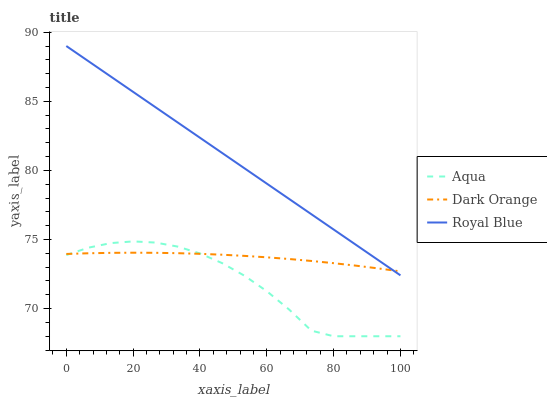Does Aqua have the minimum area under the curve?
Answer yes or no. Yes. Does Royal Blue have the maximum area under the curve?
Answer yes or no. Yes. Does Royal Blue have the minimum area under the curve?
Answer yes or no. No. Does Aqua have the maximum area under the curve?
Answer yes or no. No. Is Royal Blue the smoothest?
Answer yes or no. Yes. Is Aqua the roughest?
Answer yes or no. Yes. Is Aqua the smoothest?
Answer yes or no. No. Is Royal Blue the roughest?
Answer yes or no. No. Does Aqua have the lowest value?
Answer yes or no. Yes. Does Royal Blue have the lowest value?
Answer yes or no. No. Does Royal Blue have the highest value?
Answer yes or no. Yes. Does Aqua have the highest value?
Answer yes or no. No. Is Aqua less than Royal Blue?
Answer yes or no. Yes. Is Royal Blue greater than Aqua?
Answer yes or no. Yes. Does Dark Orange intersect Royal Blue?
Answer yes or no. Yes. Is Dark Orange less than Royal Blue?
Answer yes or no. No. Is Dark Orange greater than Royal Blue?
Answer yes or no. No. Does Aqua intersect Royal Blue?
Answer yes or no. No. 